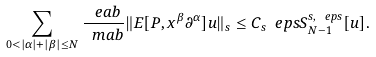Convert formula to latex. <formula><loc_0><loc_0><loc_500><loc_500>\sum _ { 0 < | \alpha | + | \beta | \leq N } \frac { \ e a b } { \ m a b } \| E [ P , x ^ { \beta } \partial ^ { \alpha } ] u \| _ { s } \leq C _ { s } \ e p s S ^ { s , \ e p s } _ { N - 1 } [ u ] .</formula> 